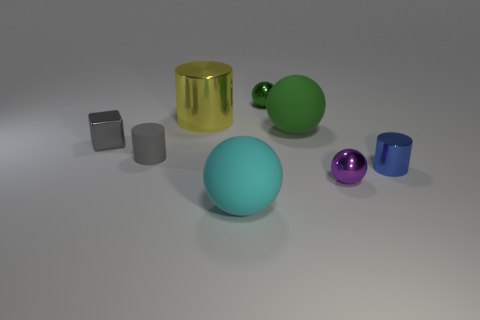What number of cyan objects are either large balls or small metal balls?
Give a very brief answer. 1. The yellow cylinder that is the same material as the small blue cylinder is what size?
Make the answer very short. Large. How many other things are the same shape as the purple object?
Provide a short and direct response. 3. Are there more metal objects in front of the block than shiny cubes that are behind the large metal cylinder?
Your answer should be very brief. Yes. Is the color of the big cylinder the same as the small shiny ball behind the gray cube?
Make the answer very short. No. There is a cyan object that is the same size as the green rubber ball; what is it made of?
Provide a succinct answer. Rubber. What number of things are brown metal spheres or small things that are on the right side of the big cyan ball?
Give a very brief answer. 3. There is a yellow cylinder; is its size the same as the cylinder to the right of the cyan matte sphere?
Keep it short and to the point. No. How many spheres are either big green objects or tiny blue metal objects?
Give a very brief answer. 1. How many things are both in front of the large shiny cylinder and right of the small gray metallic object?
Provide a short and direct response. 5. 